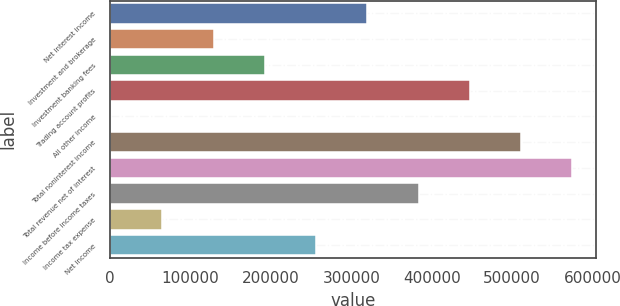Convert chart to OTSL. <chart><loc_0><loc_0><loc_500><loc_500><bar_chart><fcel>Net interest income<fcel>Investment and brokerage<fcel>Investment banking fees<fcel>Trading account profits<fcel>All other income<fcel>Total noninterest income<fcel>Total revenue net of interest<fcel>Income before income taxes<fcel>Income tax expense<fcel>Net income<nl><fcel>319822<fcel>128512<fcel>192282<fcel>447363<fcel>972<fcel>511133<fcel>574903<fcel>383593<fcel>64742.1<fcel>256052<nl></chart> 